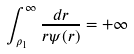<formula> <loc_0><loc_0><loc_500><loc_500>\int _ { \rho _ { 1 } } ^ { \infty } \frac { d r } { r \psi ( r ) } = + \infty</formula> 